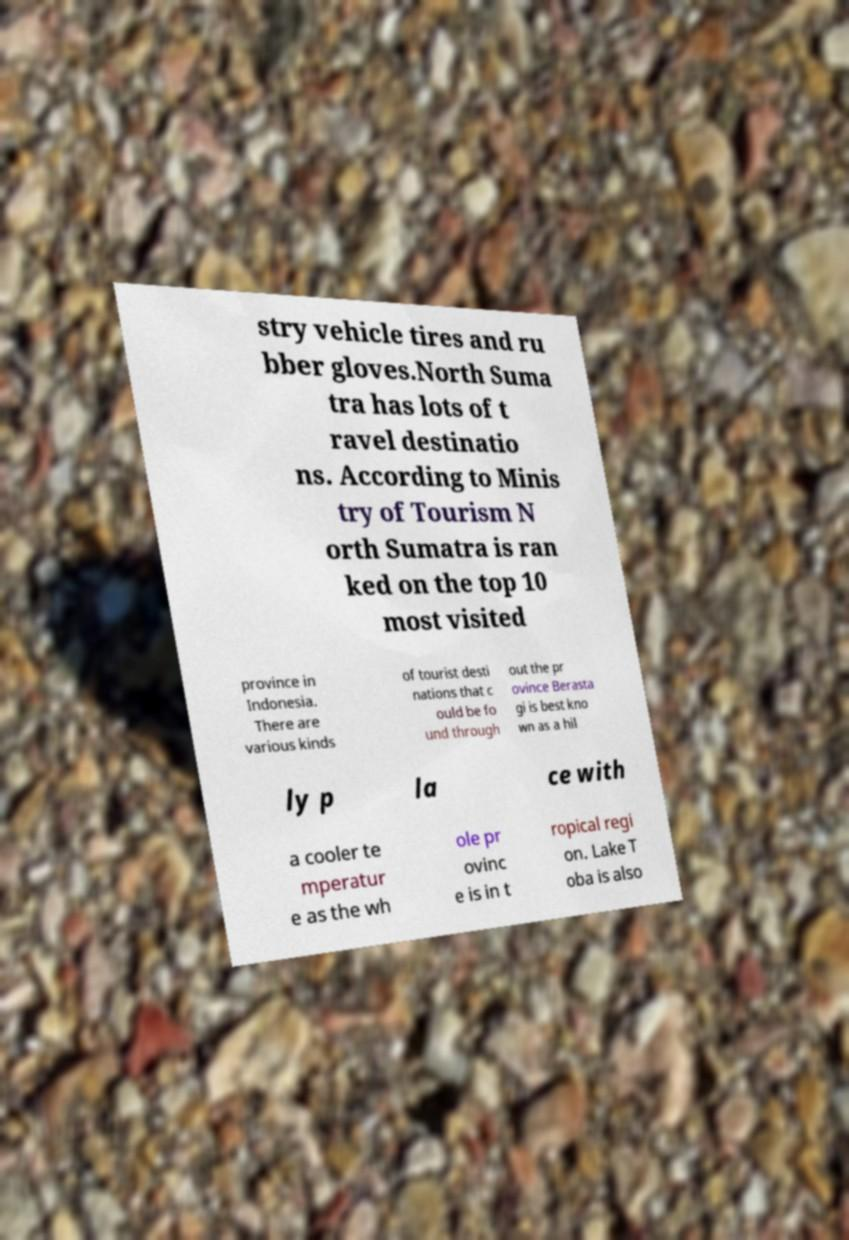What messages or text are displayed in this image? I need them in a readable, typed format. stry vehicle tires and ru bber gloves.North Suma tra has lots of t ravel destinatio ns. According to Minis try of Tourism N orth Sumatra is ran ked on the top 10 most visited province in Indonesia. There are various kinds of tourist desti nations that c ould be fo und through out the pr ovince Berasta gi is best kno wn as a hil ly p la ce with a cooler te mperatur e as the wh ole pr ovinc e is in t ropical regi on. Lake T oba is also 